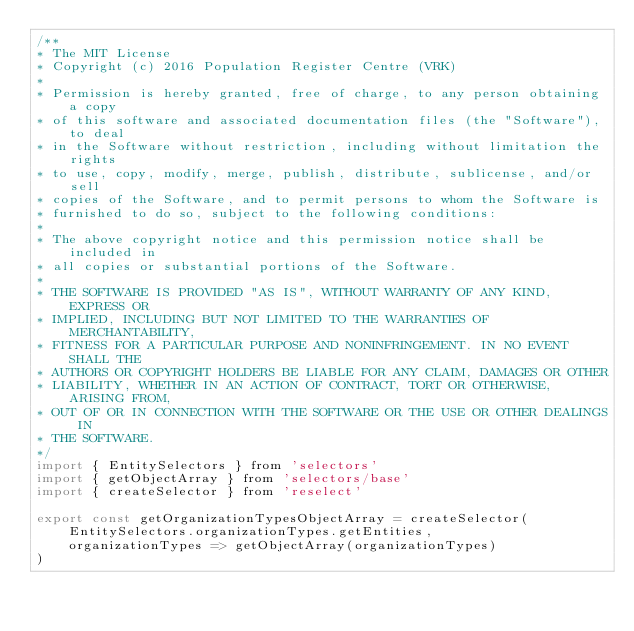<code> <loc_0><loc_0><loc_500><loc_500><_JavaScript_>/**
* The MIT License
* Copyright (c) 2016 Population Register Centre (VRK)
*
* Permission is hereby granted, free of charge, to any person obtaining a copy
* of this software and associated documentation files (the "Software"), to deal
* in the Software without restriction, including without limitation the rights
* to use, copy, modify, merge, publish, distribute, sublicense, and/or sell
* copies of the Software, and to permit persons to whom the Software is
* furnished to do so, subject to the following conditions:
*
* The above copyright notice and this permission notice shall be included in
* all copies or substantial portions of the Software.
*
* THE SOFTWARE IS PROVIDED "AS IS", WITHOUT WARRANTY OF ANY KIND, EXPRESS OR
* IMPLIED, INCLUDING BUT NOT LIMITED TO THE WARRANTIES OF MERCHANTABILITY,
* FITNESS FOR A PARTICULAR PURPOSE AND NONINFRINGEMENT. IN NO EVENT SHALL THE
* AUTHORS OR COPYRIGHT HOLDERS BE LIABLE FOR ANY CLAIM, DAMAGES OR OTHER
* LIABILITY, WHETHER IN AN ACTION OF CONTRACT, TORT OR OTHERWISE, ARISING FROM,
* OUT OF OR IN CONNECTION WITH THE SOFTWARE OR THE USE OR OTHER DEALINGS IN
* THE SOFTWARE.
*/
import { EntitySelectors } from 'selectors'
import { getObjectArray } from 'selectors/base'
import { createSelector } from 'reselect'

export const getOrganizationTypesObjectArray = createSelector(
    EntitySelectors.organizationTypes.getEntities,
    organizationTypes => getObjectArray(organizationTypes)
)
</code> 